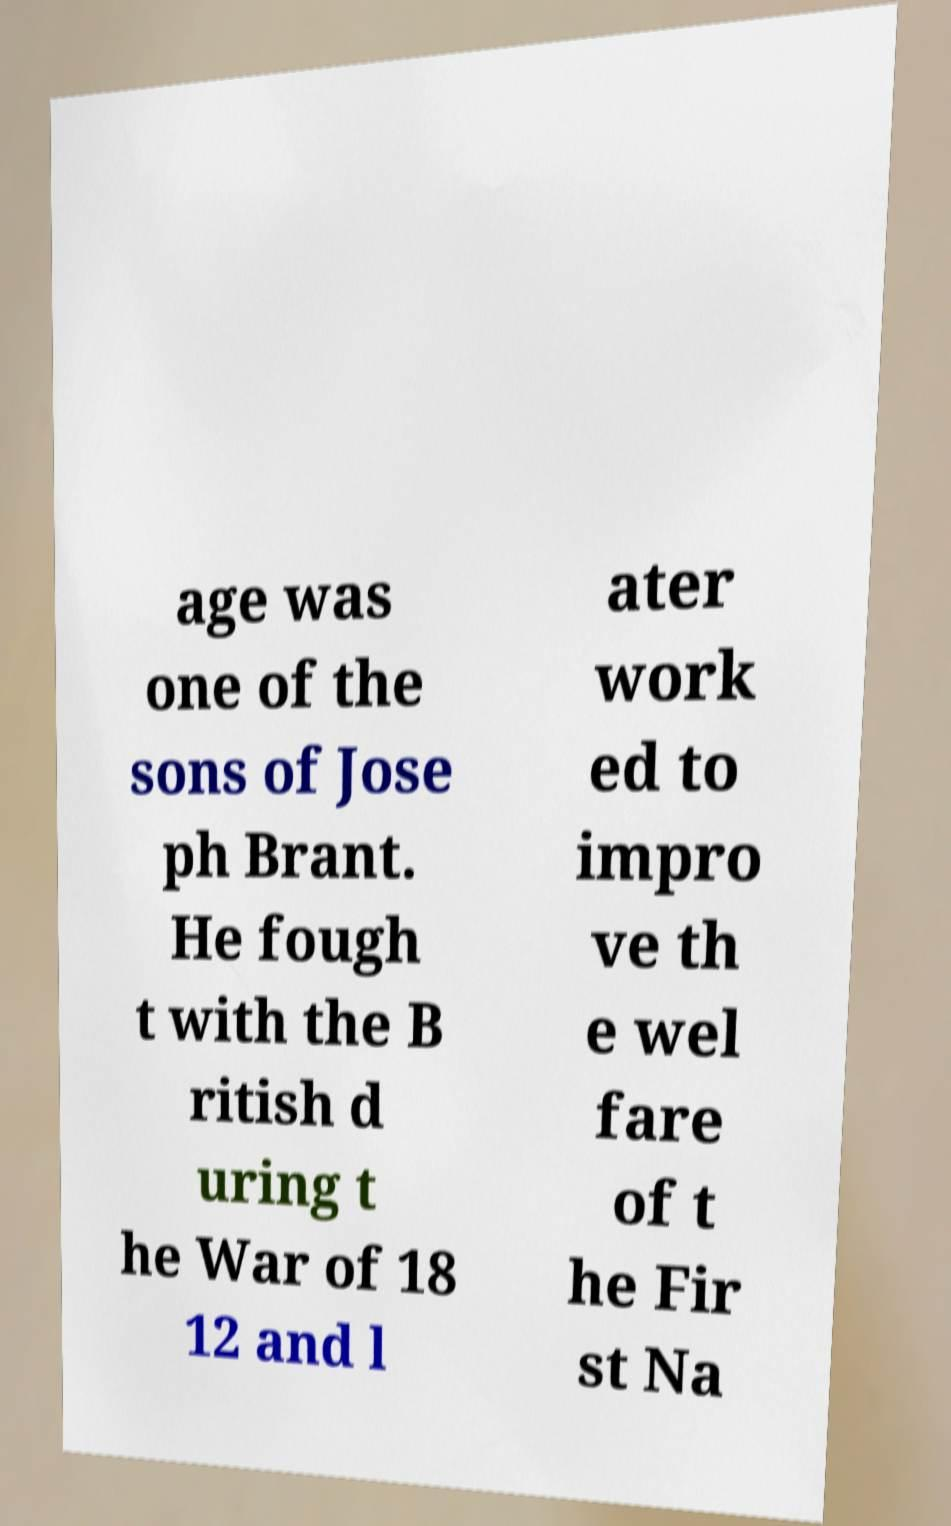Could you extract and type out the text from this image? age was one of the sons of Jose ph Brant. He fough t with the B ritish d uring t he War of 18 12 and l ater work ed to impro ve th e wel fare of t he Fir st Na 